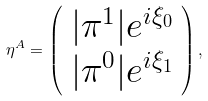Convert formula to latex. <formula><loc_0><loc_0><loc_500><loc_500>\eta ^ { A } = \left ( \begin{array} { c } | \pi ^ { 1 } | e ^ { i \xi _ { 0 } } \\ | \pi ^ { 0 } | e ^ { i \xi _ { 1 } } \\ \end{array} \right ) ,</formula> 